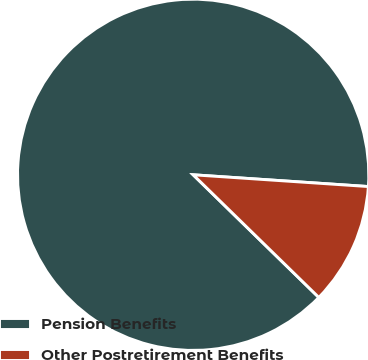Convert chart to OTSL. <chart><loc_0><loc_0><loc_500><loc_500><pie_chart><fcel>Pension Benefits<fcel>Other Postretirement Benefits<nl><fcel>88.76%<fcel>11.24%<nl></chart> 